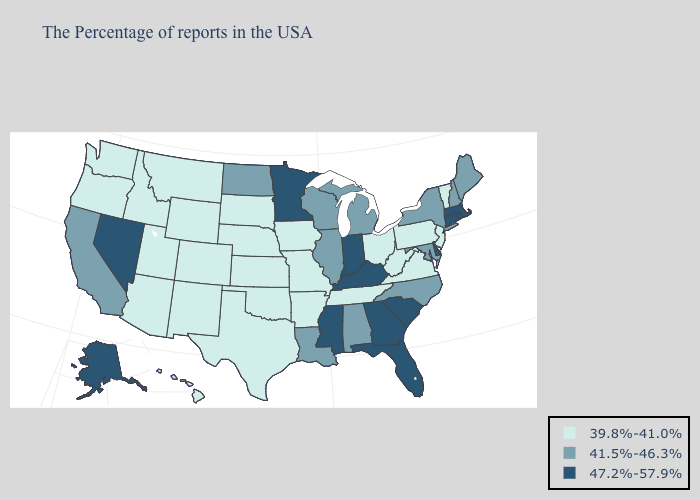Name the states that have a value in the range 39.8%-41.0%?
Give a very brief answer. Vermont, New Jersey, Pennsylvania, Virginia, West Virginia, Ohio, Tennessee, Missouri, Arkansas, Iowa, Kansas, Nebraska, Oklahoma, Texas, South Dakota, Wyoming, Colorado, New Mexico, Utah, Montana, Arizona, Idaho, Washington, Oregon, Hawaii. Among the states that border Indiana , which have the lowest value?
Short answer required. Ohio. What is the value of Mississippi?
Keep it brief. 47.2%-57.9%. Does Michigan have the same value as Colorado?
Be succinct. No. What is the highest value in states that border Mississippi?
Short answer required. 41.5%-46.3%. Does Alabama have the same value as New Hampshire?
Concise answer only. Yes. What is the value of Kentucky?
Be succinct. 47.2%-57.9%. Does the first symbol in the legend represent the smallest category?
Give a very brief answer. Yes. Name the states that have a value in the range 47.2%-57.9%?
Write a very short answer. Massachusetts, Rhode Island, Connecticut, Delaware, South Carolina, Florida, Georgia, Kentucky, Indiana, Mississippi, Minnesota, Nevada, Alaska. Name the states that have a value in the range 39.8%-41.0%?
Be succinct. Vermont, New Jersey, Pennsylvania, Virginia, West Virginia, Ohio, Tennessee, Missouri, Arkansas, Iowa, Kansas, Nebraska, Oklahoma, Texas, South Dakota, Wyoming, Colorado, New Mexico, Utah, Montana, Arizona, Idaho, Washington, Oregon, Hawaii. Which states have the highest value in the USA?
Quick response, please. Massachusetts, Rhode Island, Connecticut, Delaware, South Carolina, Florida, Georgia, Kentucky, Indiana, Mississippi, Minnesota, Nevada, Alaska. Which states have the lowest value in the West?
Answer briefly. Wyoming, Colorado, New Mexico, Utah, Montana, Arizona, Idaho, Washington, Oregon, Hawaii. What is the value of South Carolina?
Be succinct. 47.2%-57.9%. Name the states that have a value in the range 39.8%-41.0%?
Give a very brief answer. Vermont, New Jersey, Pennsylvania, Virginia, West Virginia, Ohio, Tennessee, Missouri, Arkansas, Iowa, Kansas, Nebraska, Oklahoma, Texas, South Dakota, Wyoming, Colorado, New Mexico, Utah, Montana, Arizona, Idaho, Washington, Oregon, Hawaii. What is the value of West Virginia?
Answer briefly. 39.8%-41.0%. 